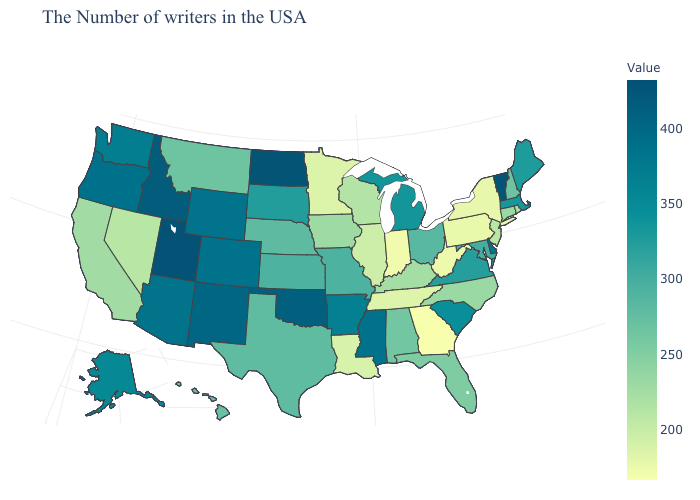Among the states that border North Carolina , does Tennessee have the highest value?
Quick response, please. No. Does Florida have a lower value than Pennsylvania?
Give a very brief answer. No. Which states have the lowest value in the USA?
Short answer required. Georgia. Does Indiana have the highest value in the MidWest?
Be succinct. No. Does Utah have the highest value in the USA?
Write a very short answer. Yes. Does Virginia have a higher value than Idaho?
Concise answer only. No. Among the states that border Nevada , does California have the lowest value?
Keep it brief. Yes. Among the states that border Oklahoma , which have the lowest value?
Give a very brief answer. Texas. 